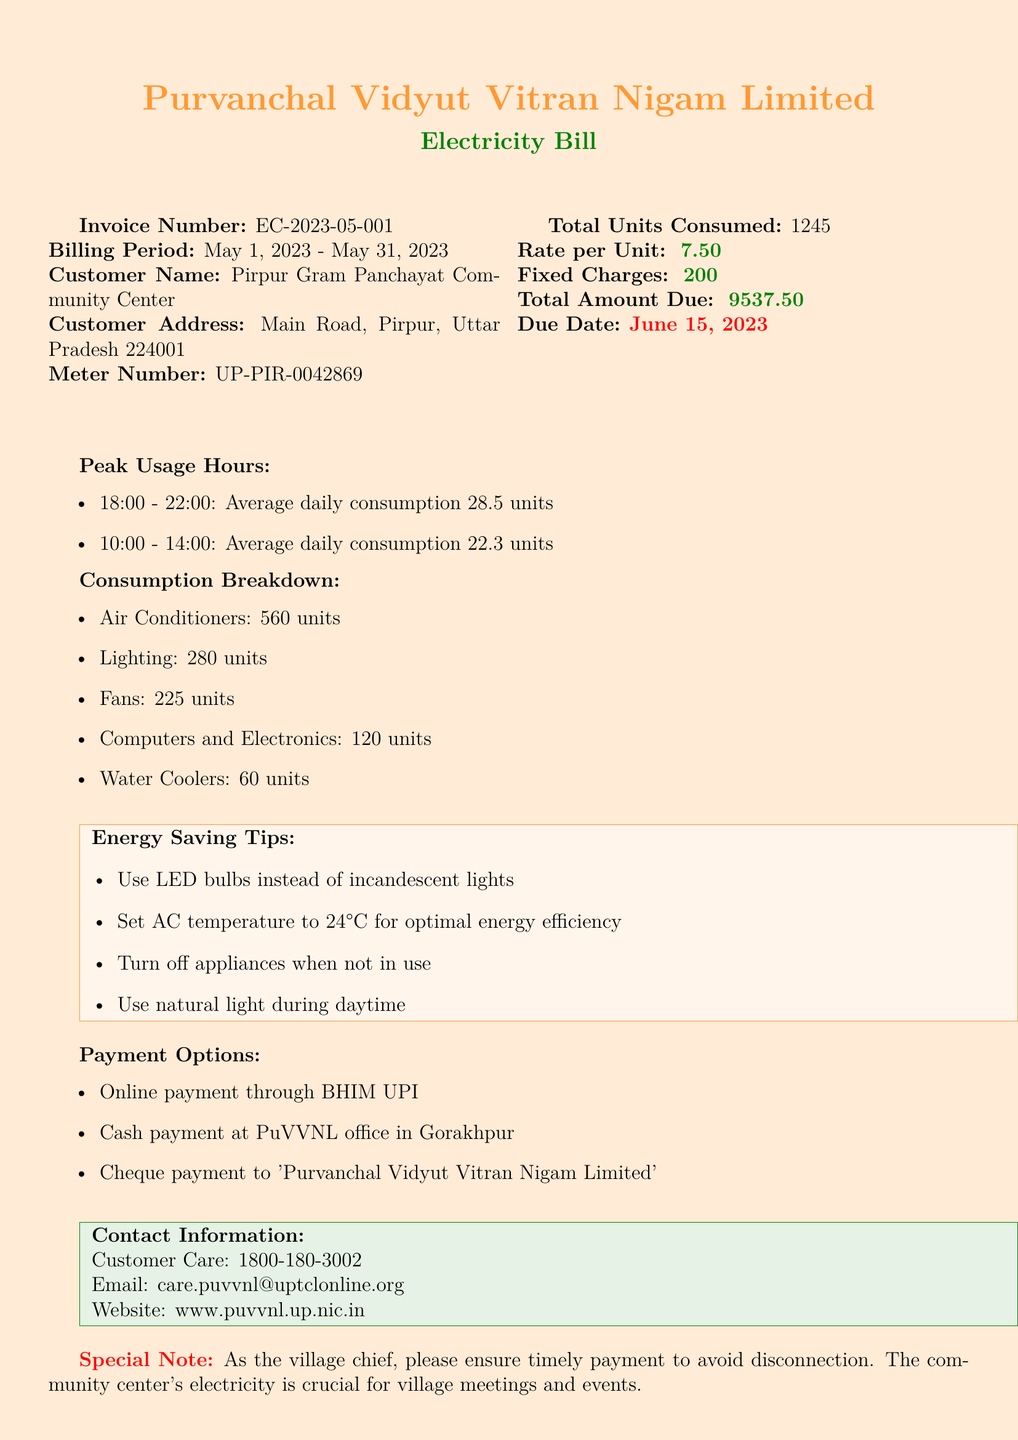what is the invoice number? The invoice number is clearly stated at the top of the document.
Answer: EC-2023-05-001 what is the total amount due? The total amount due is mentioned in the financial section of the invoice.
Answer: ₹9537.50 what is the due date for payment? The due date is indicated to ensure timely payment to avoid disconnection.
Answer: June 15, 2023 how many units were consumed by air conditioners? The consumption by air conditioners is specified in the breakdown of usage.
Answer: 560 units what are the peak usage hours? The peak usage hours are listed with the average daily consumption for each slot.
Answer: 18:00 - 22:00 and 10:00 - 14:00 what is the average daily consumption during peak hours from 18:00 to 22:00? The average daily consumption during this time slot is highlighted in the usage section.
Answer: 28.5 units who is the issuing authority for the invoice? The document identifies the entity responsible for the billing.
Answer: Purvanchal Vidyut Vitran Nigam Limited (PuVVNL) what is one of the energy saving tips provided? One of the tips is presented in a dedicated section for energy efficiency.
Answer: Use LED bulbs instead of incandescent lights 